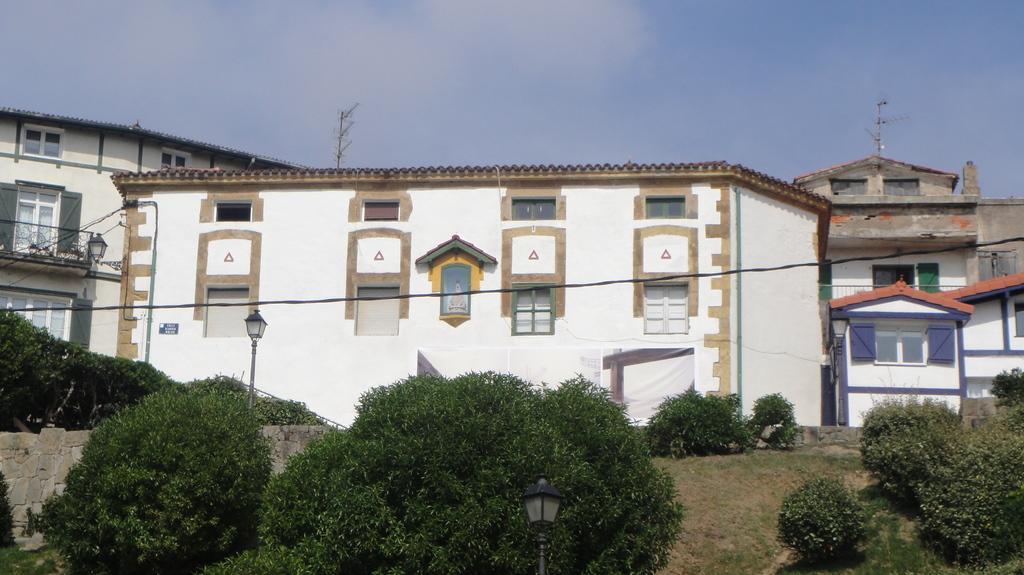In one or two sentences, can you explain what this image depicts? In the picture I can see shrubs, light poles, wires, stone wall, grass, buildings and the cloudy sky in the background. 